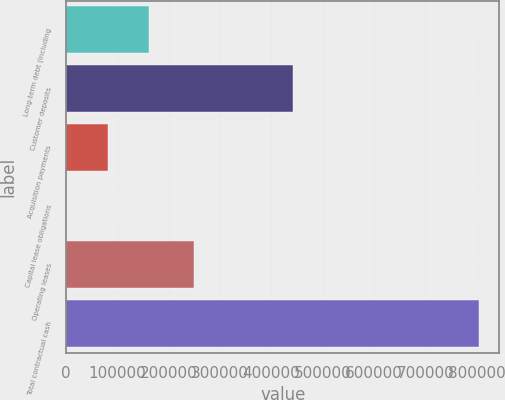Convert chart to OTSL. <chart><loc_0><loc_0><loc_500><loc_500><bar_chart><fcel>Long-term debt (including<fcel>Customer deposits<fcel>Acquisition payments<fcel>Capital lease obligations<fcel>Operating leases<fcel>Total contractual cash<nl><fcel>161289<fcel>442683<fcel>80904<fcel>519<fcel>248712<fcel>804369<nl></chart> 